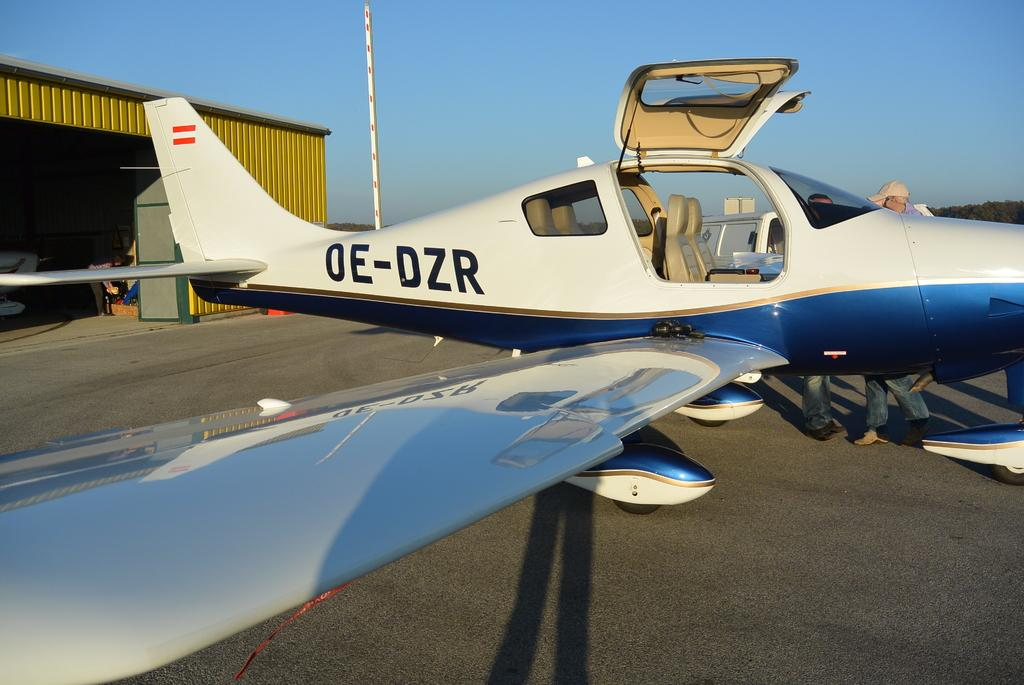<image>
Describe the image concisely. The small aircraft OE-DZR is on the tarmac with the door to the cockpit open. 